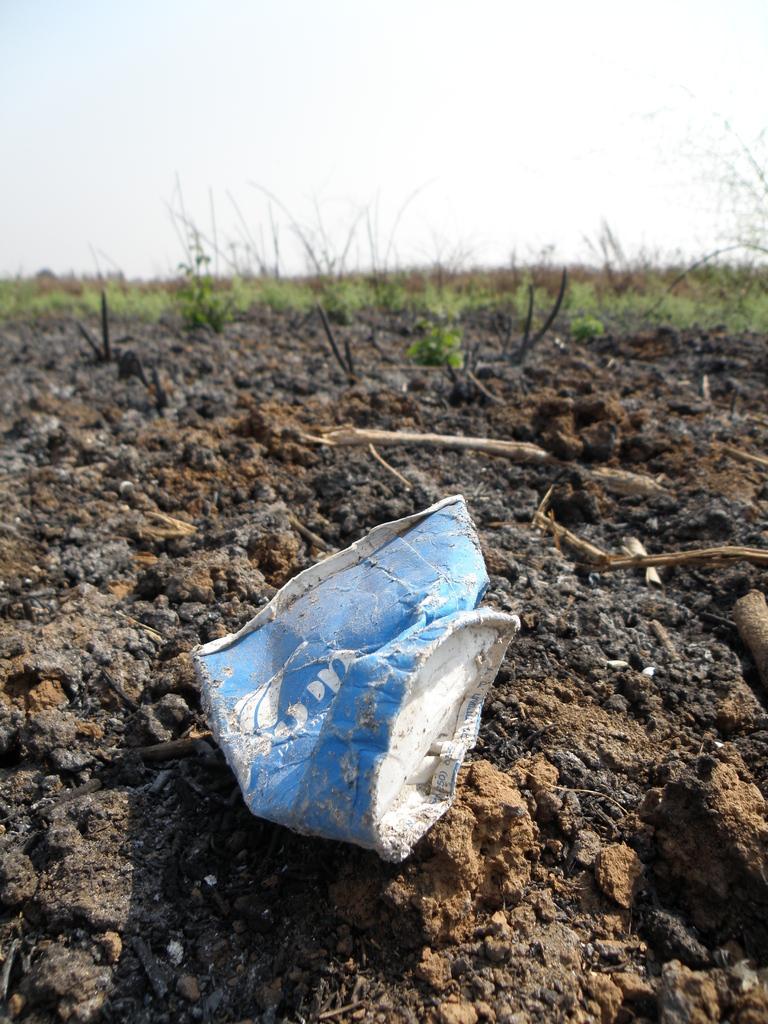Describe this image in one or two sentences. In this picture we can see an object on soil. In the background of the image we can see grass, plants and sky. 